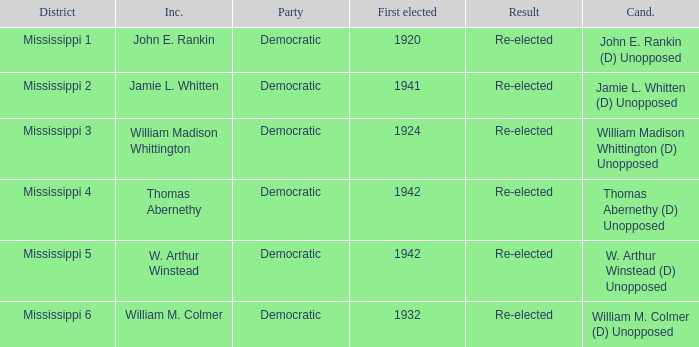What candidates are from mississippi 6? William M. Colmer (D) Unopposed. Give me the full table as a dictionary. {'header': ['District', 'Inc.', 'Party', 'First elected', 'Result', 'Cand.'], 'rows': [['Mississippi 1', 'John E. Rankin', 'Democratic', '1920', 'Re-elected', 'John E. Rankin (D) Unopposed'], ['Mississippi 2', 'Jamie L. Whitten', 'Democratic', '1941', 'Re-elected', 'Jamie L. Whitten (D) Unopposed'], ['Mississippi 3', 'William Madison Whittington', 'Democratic', '1924', 'Re-elected', 'William Madison Whittington (D) Unopposed'], ['Mississippi 4', 'Thomas Abernethy', 'Democratic', '1942', 'Re-elected', 'Thomas Abernethy (D) Unopposed'], ['Mississippi 5', 'W. Arthur Winstead', 'Democratic', '1942', 'Re-elected', 'W. Arthur Winstead (D) Unopposed'], ['Mississippi 6', 'William M. Colmer', 'Democratic', '1932', 'Re-elected', 'William M. Colmer (D) Unopposed']]} 